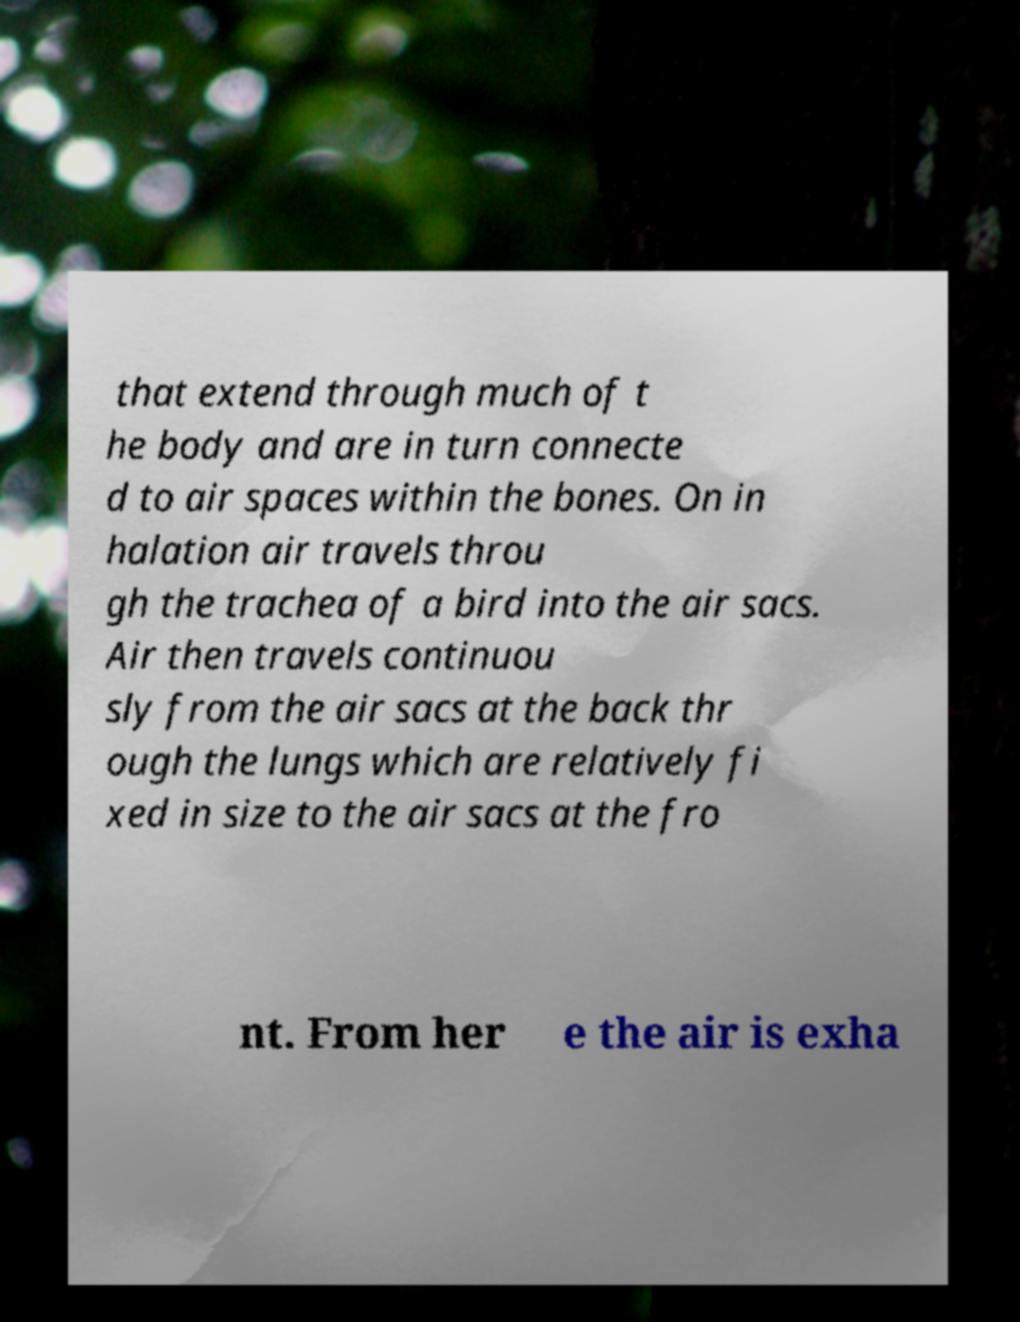Can you accurately transcribe the text from the provided image for me? that extend through much of t he body and are in turn connecte d to air spaces within the bones. On in halation air travels throu gh the trachea of a bird into the air sacs. Air then travels continuou sly from the air sacs at the back thr ough the lungs which are relatively fi xed in size to the air sacs at the fro nt. From her e the air is exha 